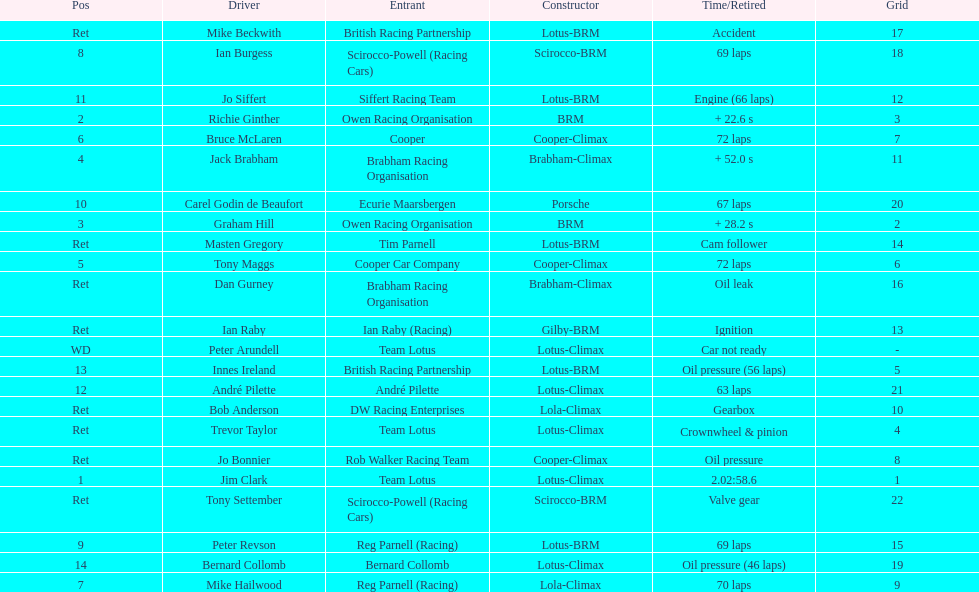Write the full table. {'header': ['Pos', 'Driver', 'Entrant', 'Constructor', 'Time/Retired', 'Grid'], 'rows': [['Ret', 'Mike Beckwith', 'British Racing Partnership', 'Lotus-BRM', 'Accident', '17'], ['8', 'Ian Burgess', 'Scirocco-Powell (Racing Cars)', 'Scirocco-BRM', '69 laps', '18'], ['11', 'Jo Siffert', 'Siffert Racing Team', 'Lotus-BRM', 'Engine (66 laps)', '12'], ['2', 'Richie Ginther', 'Owen Racing Organisation', 'BRM', '+ 22.6 s', '3'], ['6', 'Bruce McLaren', 'Cooper', 'Cooper-Climax', '72 laps', '7'], ['4', 'Jack Brabham', 'Brabham Racing Organisation', 'Brabham-Climax', '+ 52.0 s', '11'], ['10', 'Carel Godin de Beaufort', 'Ecurie Maarsbergen', 'Porsche', '67 laps', '20'], ['3', 'Graham Hill', 'Owen Racing Organisation', 'BRM', '+ 28.2 s', '2'], ['Ret', 'Masten Gregory', 'Tim Parnell', 'Lotus-BRM', 'Cam follower', '14'], ['5', 'Tony Maggs', 'Cooper Car Company', 'Cooper-Climax', '72 laps', '6'], ['Ret', 'Dan Gurney', 'Brabham Racing Organisation', 'Brabham-Climax', 'Oil leak', '16'], ['Ret', 'Ian Raby', 'Ian Raby (Racing)', 'Gilby-BRM', 'Ignition', '13'], ['WD', 'Peter Arundell', 'Team Lotus', 'Lotus-Climax', 'Car not ready', '-'], ['13', 'Innes Ireland', 'British Racing Partnership', 'Lotus-BRM', 'Oil pressure (56 laps)', '5'], ['12', 'André Pilette', 'André Pilette', 'Lotus-Climax', '63 laps', '21'], ['Ret', 'Bob Anderson', 'DW Racing Enterprises', 'Lola-Climax', 'Gearbox', '10'], ['Ret', 'Trevor Taylor', 'Team Lotus', 'Lotus-Climax', 'Crownwheel & pinion', '4'], ['Ret', 'Jo Bonnier', 'Rob Walker Racing Team', 'Cooper-Climax', 'Oil pressure', '8'], ['1', 'Jim Clark', 'Team Lotus', 'Lotus-Climax', '2.02:58.6', '1'], ['Ret', 'Tony Settember', 'Scirocco-Powell (Racing Cars)', 'Scirocco-BRM', 'Valve gear', '22'], ['9', 'Peter Revson', 'Reg Parnell (Racing)', 'Lotus-BRM', '69 laps', '15'], ['14', 'Bernard Collomb', 'Bernard Collomb', 'Lotus-Climax', 'Oil pressure (46 laps)', '19'], ['7', 'Mike Hailwood', 'Reg Parnell (Racing)', 'Lola-Climax', '70 laps', '9']]} What is the number of americans in the top 5? 1. 